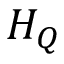Convert formula to latex. <formula><loc_0><loc_0><loc_500><loc_500>H _ { Q }</formula> 